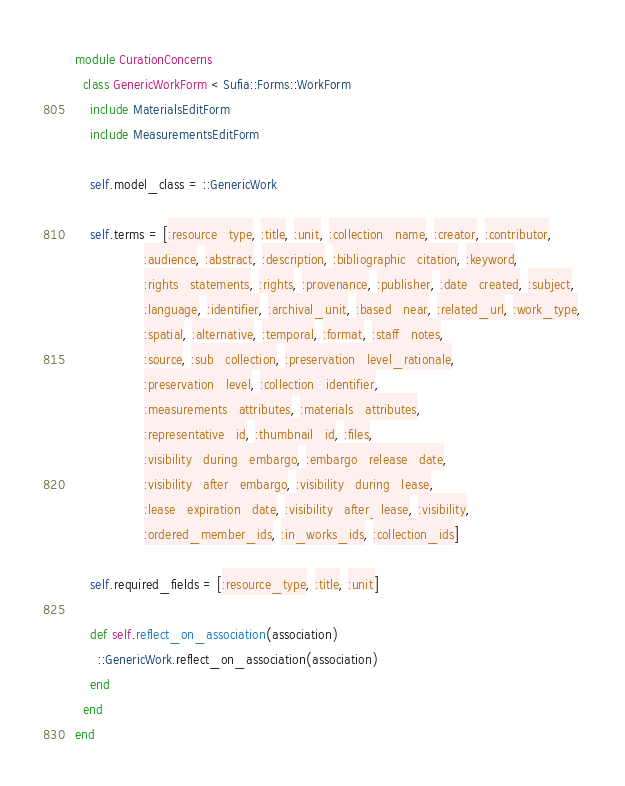<code> <loc_0><loc_0><loc_500><loc_500><_Ruby_>module CurationConcerns
  class GenericWorkForm < Sufia::Forms::WorkForm
    include MaterialsEditForm
    include MeasurementsEditForm

    self.model_class = ::GenericWork

    self.terms = [:resource_type, :title, :unit, :collection_name, :creator, :contributor,
                  :audience, :abstract, :description, :bibliographic_citation, :keyword,
                  :rights_statements, :rights, :provenance, :publisher, :date_created, :subject,
                  :language, :identifier, :archival_unit, :based_near, :related_url, :work_type,
                  :spatial, :alternative, :temporal, :format, :staff_notes,
                  :source, :sub_collection, :preservation_level_rationale,
                  :preservation_level, :collection_identifier,
                  :measurements_attributes, :materials_attributes,
                  :representative_id, :thumbnail_id, :files,
                  :visibility_during_embargo, :embargo_release_date,
                  :visibility_after_embargo, :visibility_during_lease,
                  :lease_expiration_date, :visibility_after_lease, :visibility,
                  :ordered_member_ids, :in_works_ids, :collection_ids]

    self.required_fields = [:resource_type, :title, :unit]

    def self.reflect_on_association(association)
      ::GenericWork.reflect_on_association(association)
    end
  end
end
</code> 